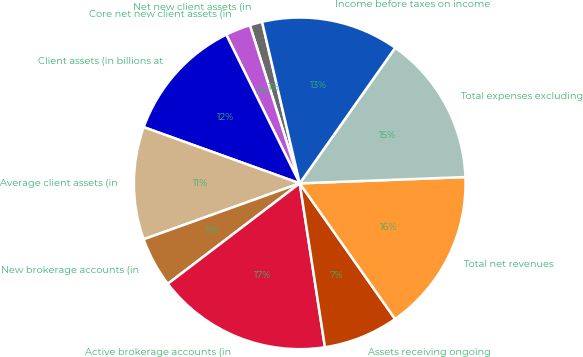Convert chart. <chart><loc_0><loc_0><loc_500><loc_500><pie_chart><fcel>Net new client assets (in<fcel>Core net new client assets (in<fcel>Client assets (in billions at<fcel>Average client assets (in<fcel>New brokerage accounts (in<fcel>Active brokerage accounts (in<fcel>Assets receiving ongoing<fcel>Total net revenues<fcel>Total expenses excluding<fcel>Income before taxes on income<nl><fcel>1.22%<fcel>2.44%<fcel>12.19%<fcel>10.98%<fcel>4.88%<fcel>17.07%<fcel>7.32%<fcel>15.85%<fcel>14.63%<fcel>13.41%<nl></chart> 